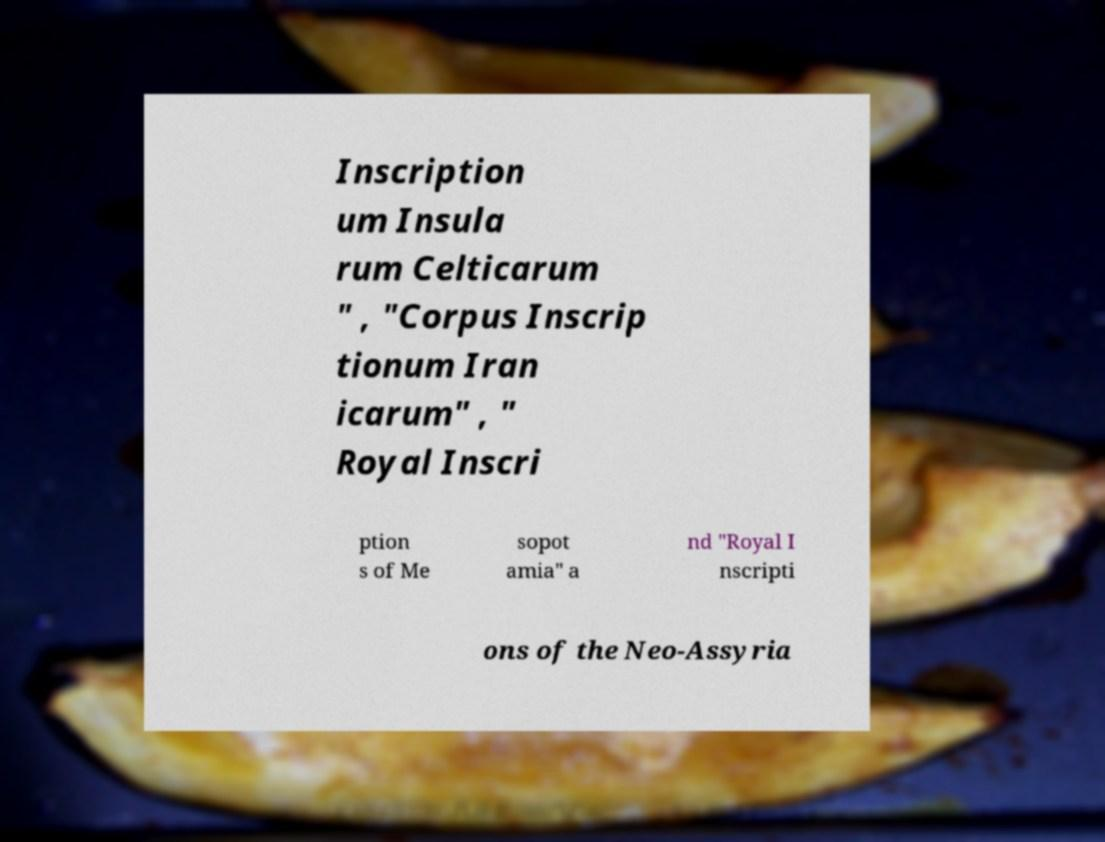Please read and relay the text visible in this image. What does it say? Inscription um Insula rum Celticarum " , "Corpus Inscrip tionum Iran icarum" , " Royal Inscri ption s of Me sopot amia" a nd "Royal I nscripti ons of the Neo-Assyria 